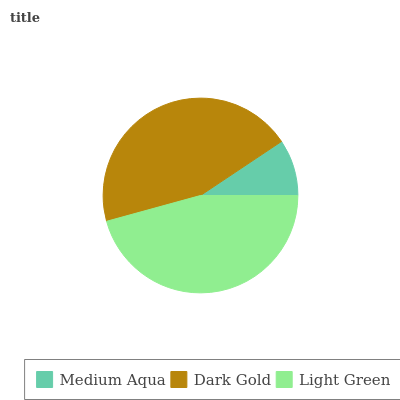Is Medium Aqua the minimum?
Answer yes or no. Yes. Is Light Green the maximum?
Answer yes or no. Yes. Is Dark Gold the minimum?
Answer yes or no. No. Is Dark Gold the maximum?
Answer yes or no. No. Is Dark Gold greater than Medium Aqua?
Answer yes or no. Yes. Is Medium Aqua less than Dark Gold?
Answer yes or no. Yes. Is Medium Aqua greater than Dark Gold?
Answer yes or no. No. Is Dark Gold less than Medium Aqua?
Answer yes or no. No. Is Dark Gold the high median?
Answer yes or no. Yes. Is Dark Gold the low median?
Answer yes or no. Yes. Is Medium Aqua the high median?
Answer yes or no. No. Is Medium Aqua the low median?
Answer yes or no. No. 